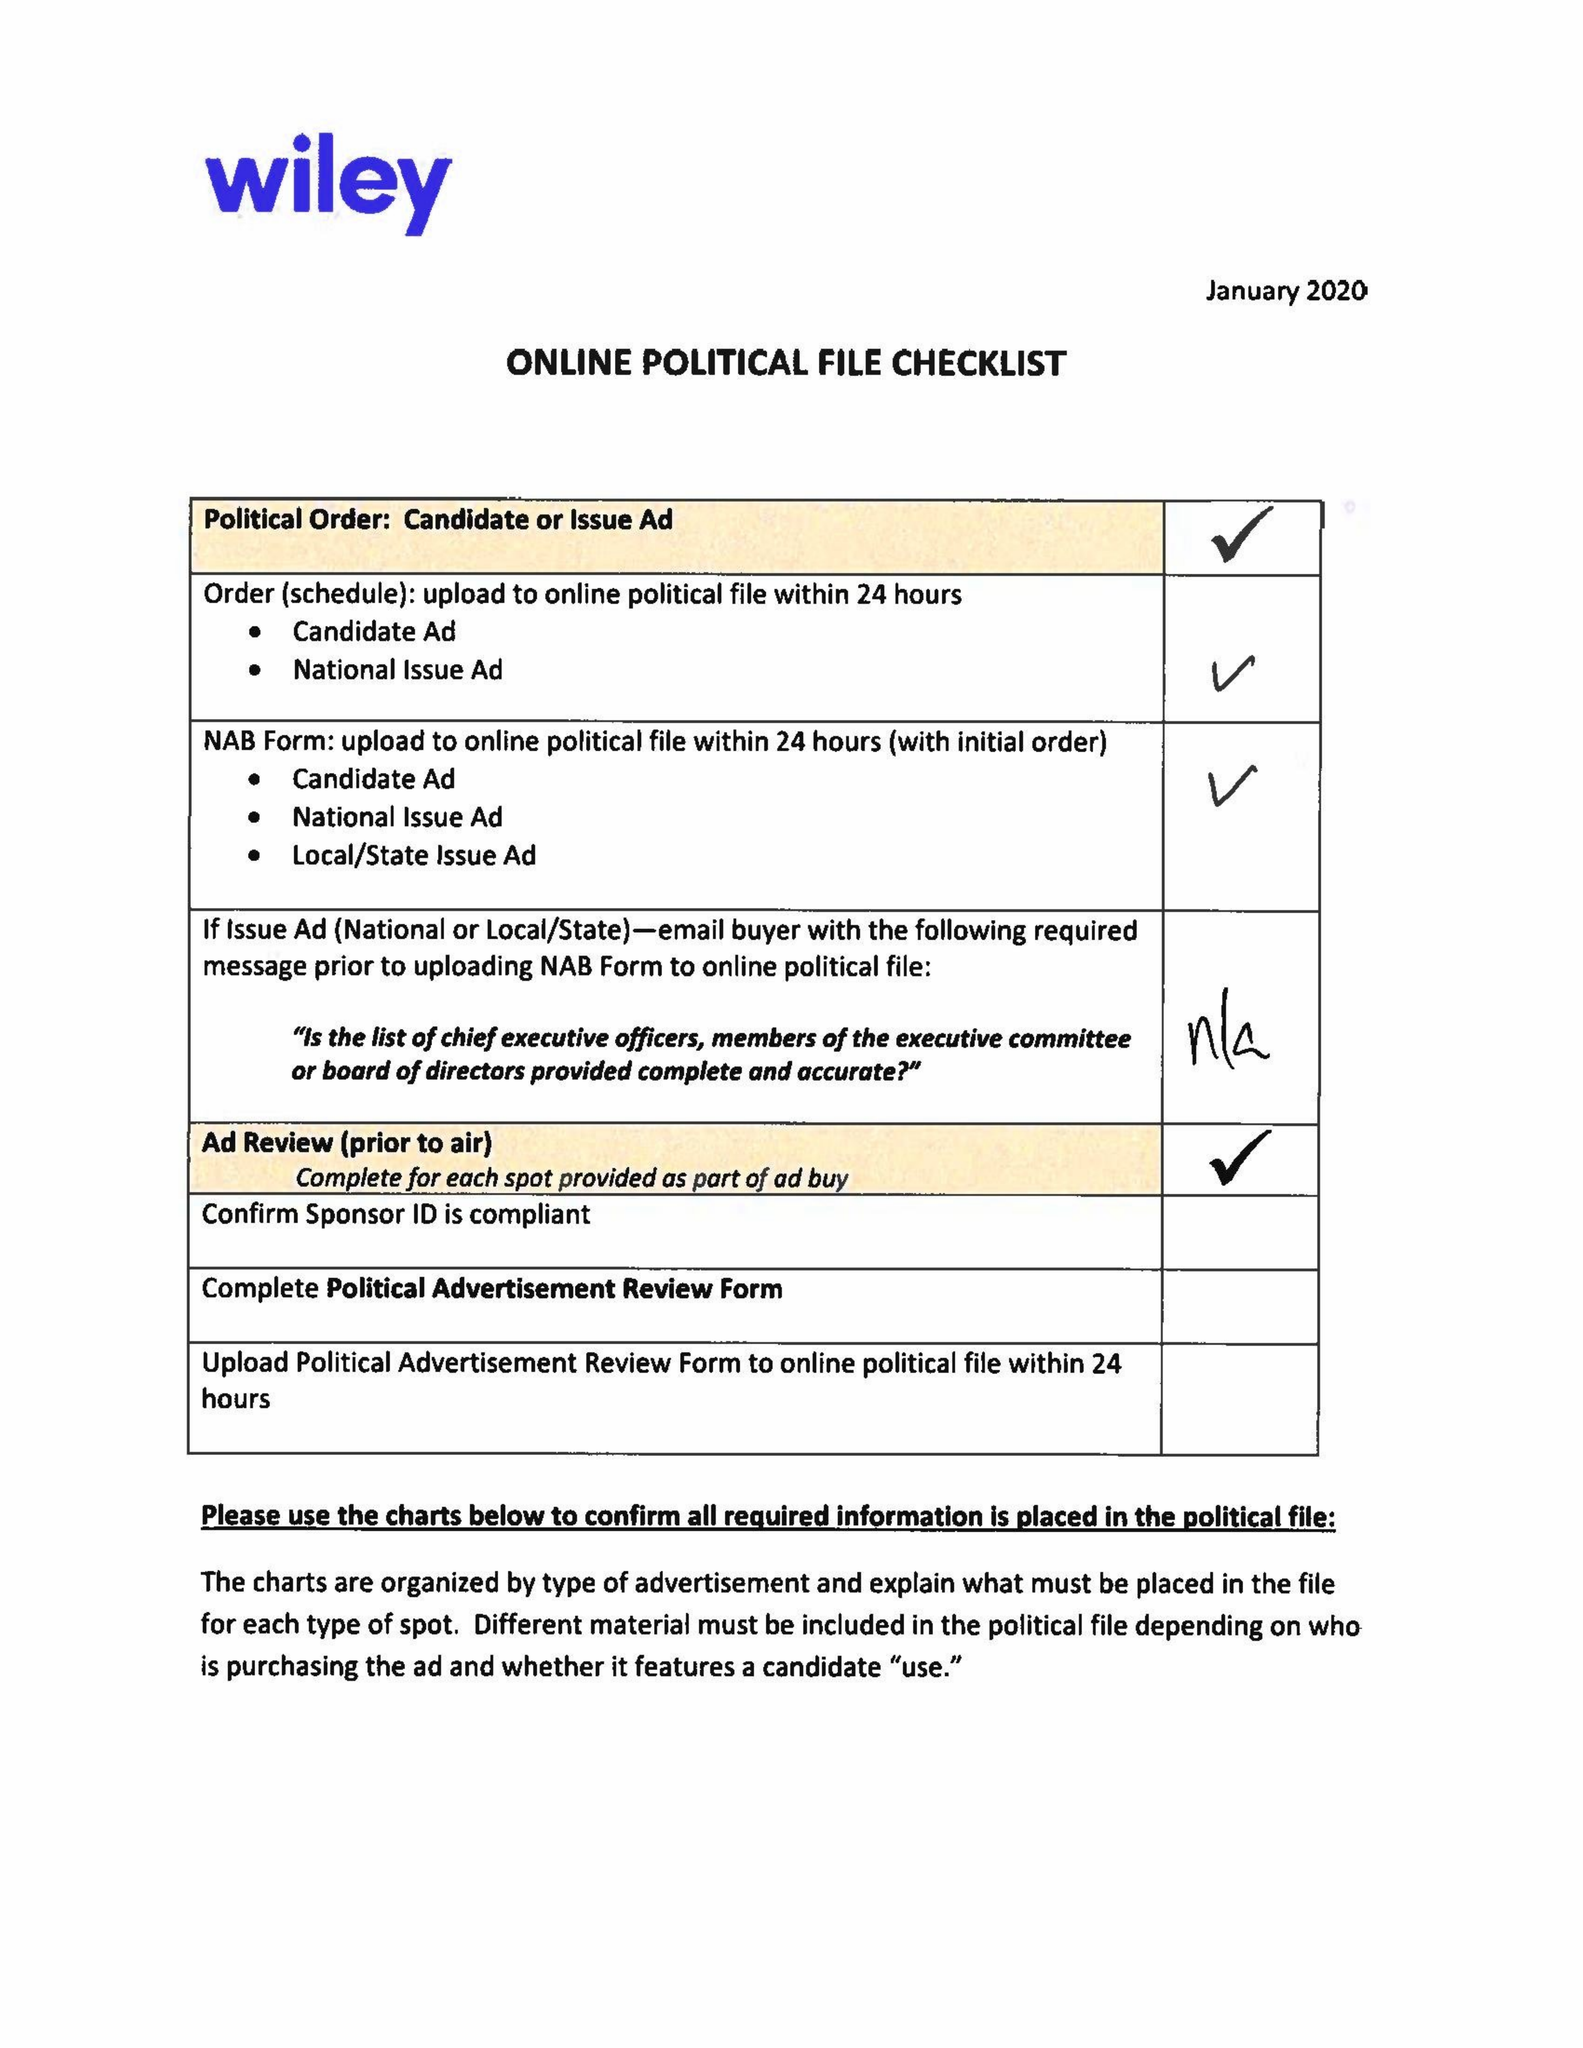What is the value for the flight_from?
Answer the question using a single word or phrase. 02/18/20 